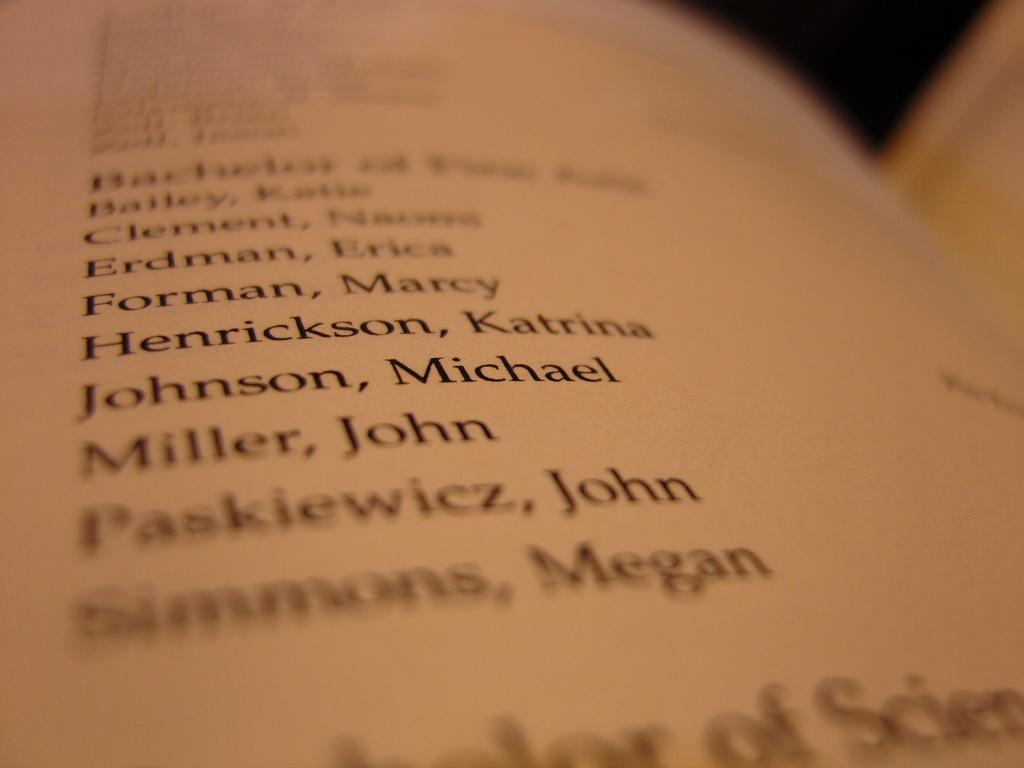<image>
Render a clear and concise summary of the photo. A list of names includes a female known as Marcy Forman. 